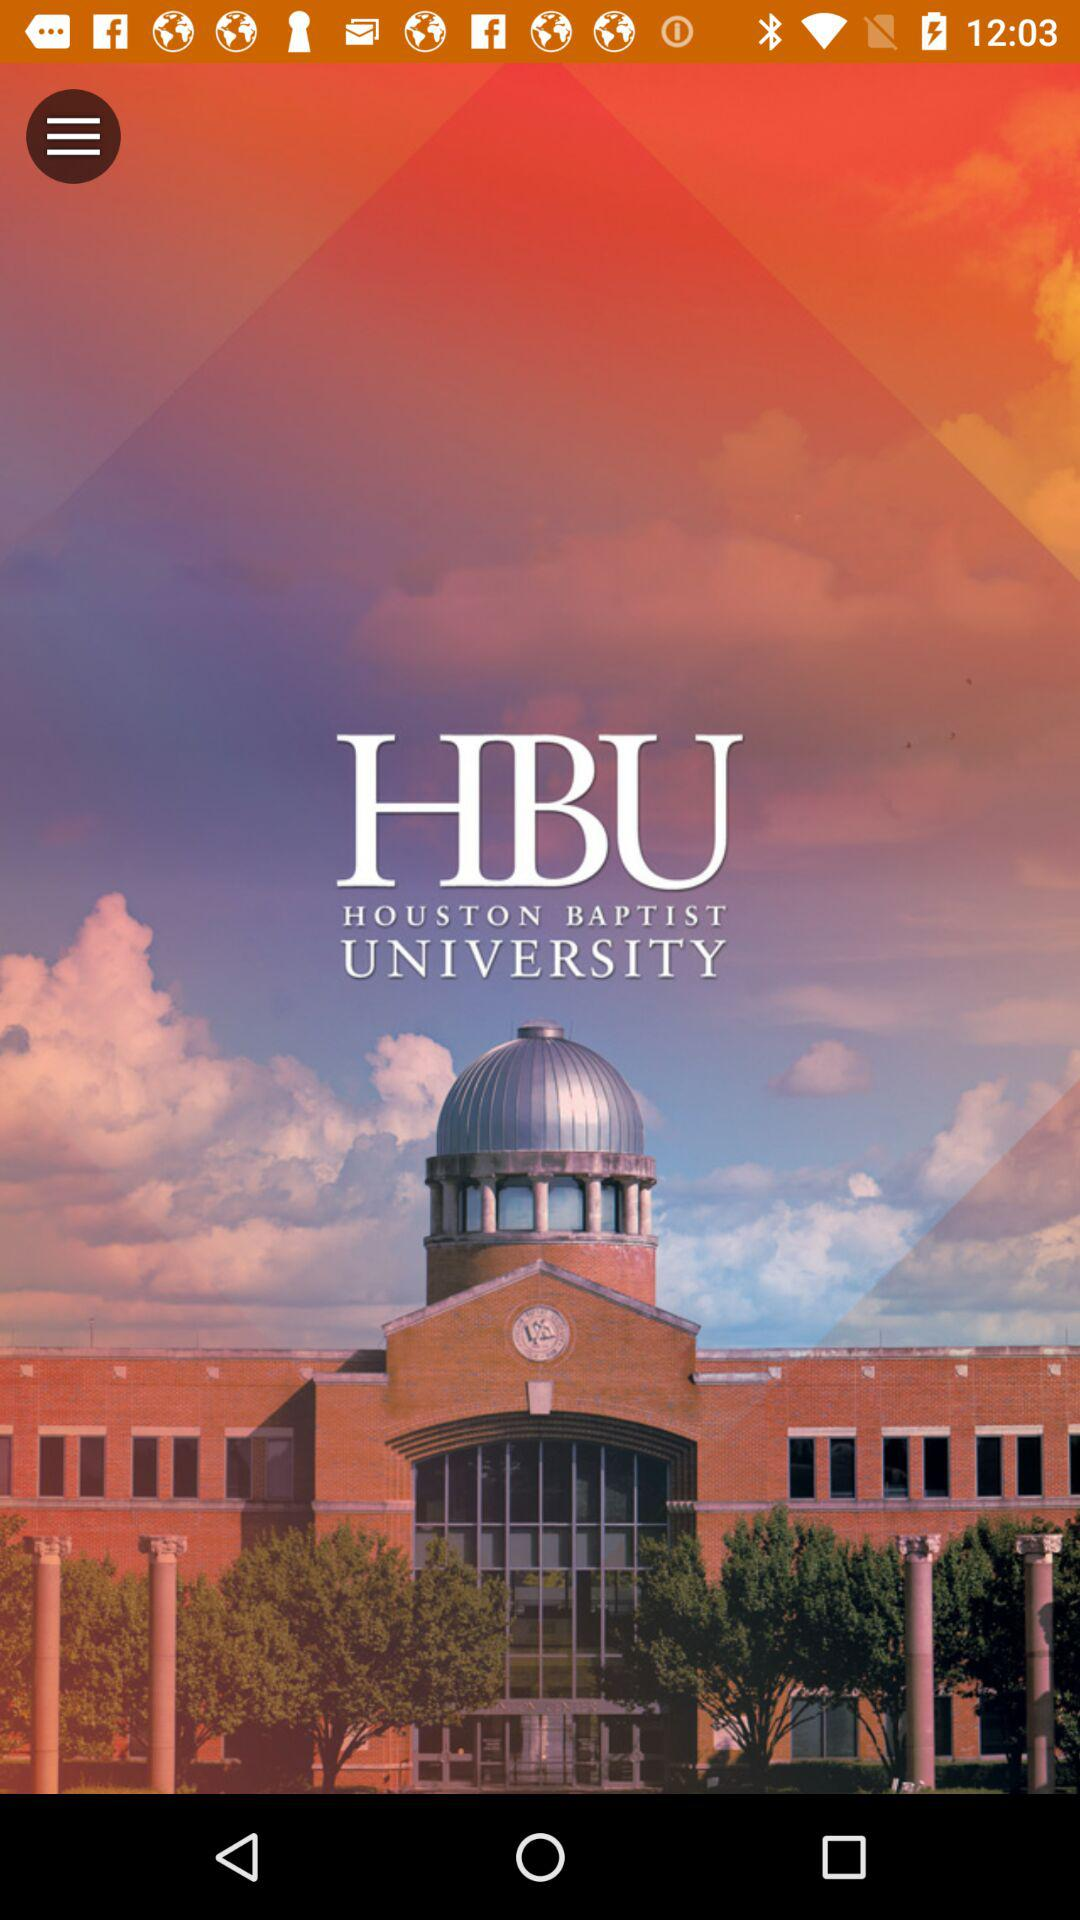What is the name of the university? The name of the university is "HOUSTON BAPTIST UNIVERSITY". 